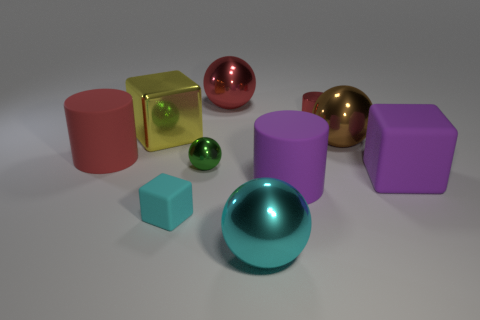Subtract all blocks. How many objects are left? 7 Subtract 0 gray blocks. How many objects are left? 10 Subtract all tiny purple rubber objects. Subtract all large red objects. How many objects are left? 8 Add 6 small cyan matte blocks. How many small cyan matte blocks are left? 7 Add 1 purple objects. How many purple objects exist? 3 